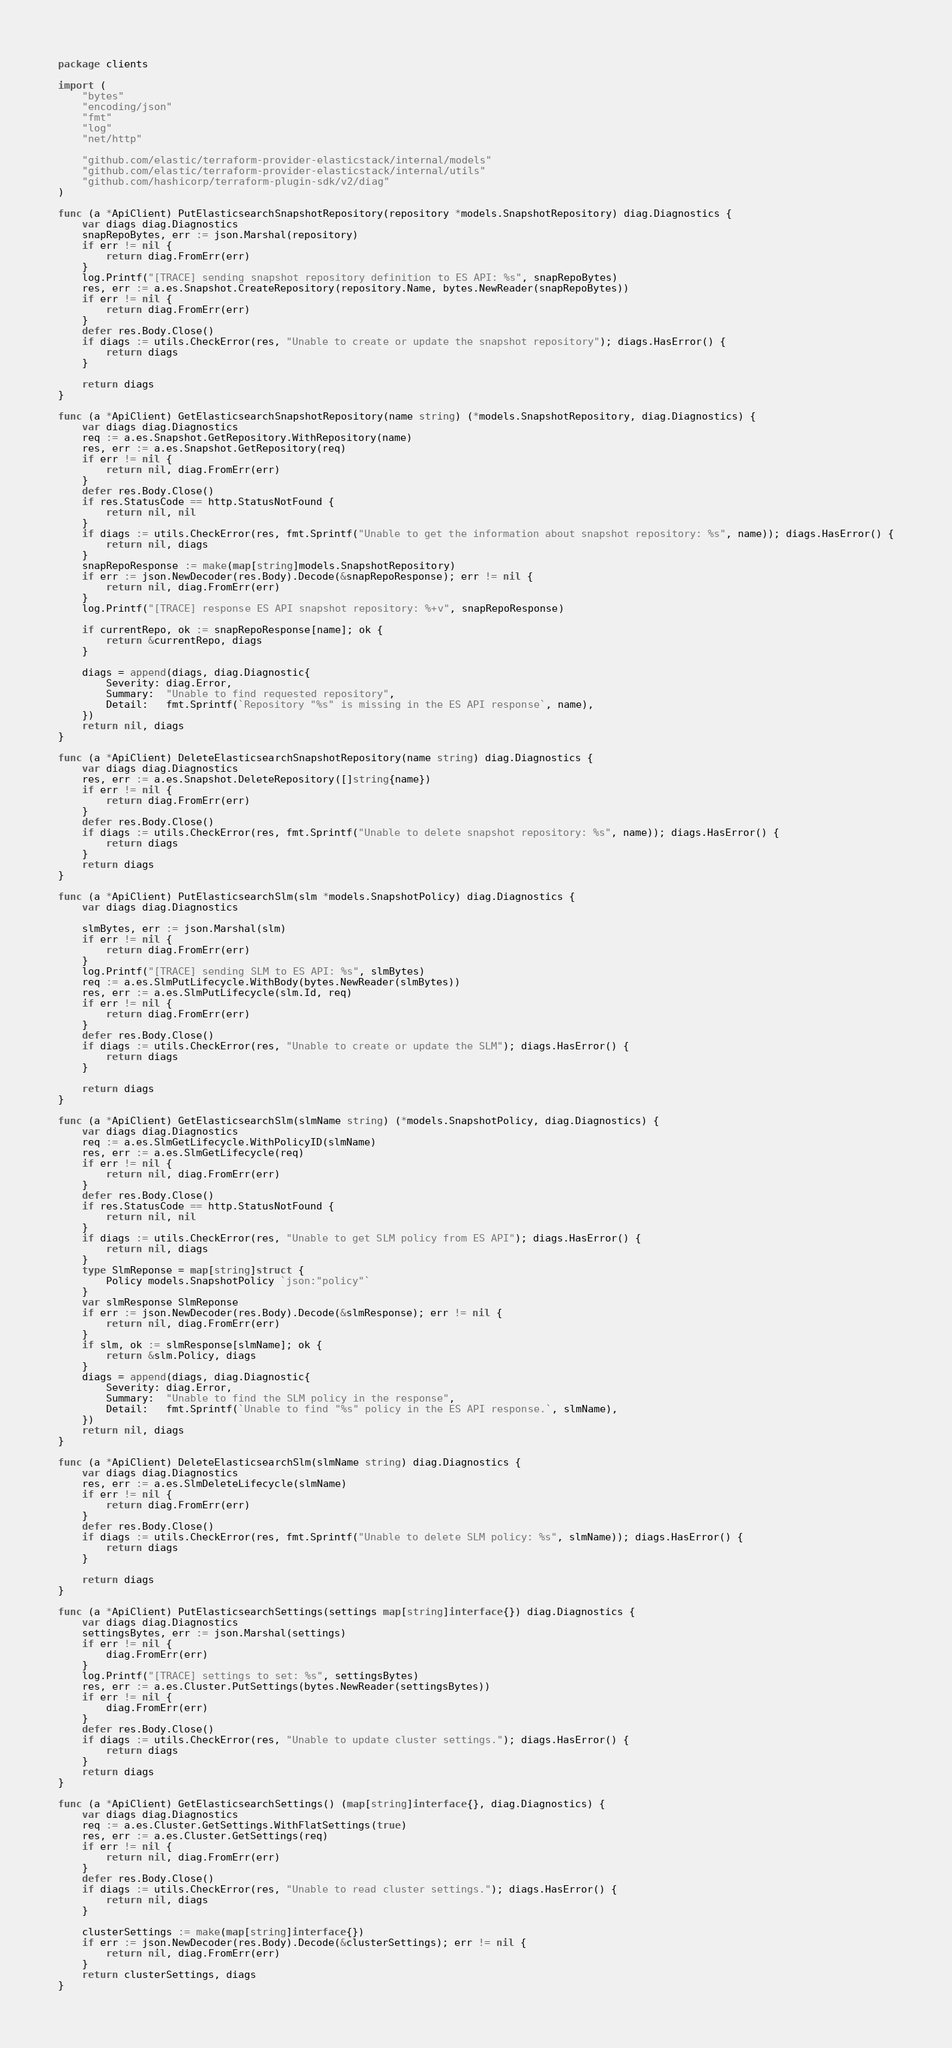Convert code to text. <code><loc_0><loc_0><loc_500><loc_500><_Go_>package clients

import (
	"bytes"
	"encoding/json"
	"fmt"
	"log"
	"net/http"

	"github.com/elastic/terraform-provider-elasticstack/internal/models"
	"github.com/elastic/terraform-provider-elasticstack/internal/utils"
	"github.com/hashicorp/terraform-plugin-sdk/v2/diag"
)

func (a *ApiClient) PutElasticsearchSnapshotRepository(repository *models.SnapshotRepository) diag.Diagnostics {
	var diags diag.Diagnostics
	snapRepoBytes, err := json.Marshal(repository)
	if err != nil {
		return diag.FromErr(err)
	}
	log.Printf("[TRACE] sending snapshot repository definition to ES API: %s", snapRepoBytes)
	res, err := a.es.Snapshot.CreateRepository(repository.Name, bytes.NewReader(snapRepoBytes))
	if err != nil {
		return diag.FromErr(err)
	}
	defer res.Body.Close()
	if diags := utils.CheckError(res, "Unable to create or update the snapshot repository"); diags.HasError() {
		return diags
	}

	return diags
}

func (a *ApiClient) GetElasticsearchSnapshotRepository(name string) (*models.SnapshotRepository, diag.Diagnostics) {
	var diags diag.Diagnostics
	req := a.es.Snapshot.GetRepository.WithRepository(name)
	res, err := a.es.Snapshot.GetRepository(req)
	if err != nil {
		return nil, diag.FromErr(err)
	}
	defer res.Body.Close()
	if res.StatusCode == http.StatusNotFound {
		return nil, nil
	}
	if diags := utils.CheckError(res, fmt.Sprintf("Unable to get the information about snapshot repository: %s", name)); diags.HasError() {
		return nil, diags
	}
	snapRepoResponse := make(map[string]models.SnapshotRepository)
	if err := json.NewDecoder(res.Body).Decode(&snapRepoResponse); err != nil {
		return nil, diag.FromErr(err)
	}
	log.Printf("[TRACE] response ES API snapshot repository: %+v", snapRepoResponse)

	if currentRepo, ok := snapRepoResponse[name]; ok {
		return &currentRepo, diags
	}

	diags = append(diags, diag.Diagnostic{
		Severity: diag.Error,
		Summary:  "Unable to find requested repository",
		Detail:   fmt.Sprintf(`Repository "%s" is missing in the ES API response`, name),
	})
	return nil, diags
}

func (a *ApiClient) DeleteElasticsearchSnapshotRepository(name string) diag.Diagnostics {
	var diags diag.Diagnostics
	res, err := a.es.Snapshot.DeleteRepository([]string{name})
	if err != nil {
		return diag.FromErr(err)
	}
	defer res.Body.Close()
	if diags := utils.CheckError(res, fmt.Sprintf("Unable to delete snapshot repository: %s", name)); diags.HasError() {
		return diags
	}
	return diags
}

func (a *ApiClient) PutElasticsearchSlm(slm *models.SnapshotPolicy) diag.Diagnostics {
	var diags diag.Diagnostics

	slmBytes, err := json.Marshal(slm)
	if err != nil {
		return diag.FromErr(err)
	}
	log.Printf("[TRACE] sending SLM to ES API: %s", slmBytes)
	req := a.es.SlmPutLifecycle.WithBody(bytes.NewReader(slmBytes))
	res, err := a.es.SlmPutLifecycle(slm.Id, req)
	if err != nil {
		return diag.FromErr(err)
	}
	defer res.Body.Close()
	if diags := utils.CheckError(res, "Unable to create or update the SLM"); diags.HasError() {
		return diags
	}

	return diags
}

func (a *ApiClient) GetElasticsearchSlm(slmName string) (*models.SnapshotPolicy, diag.Diagnostics) {
	var diags diag.Diagnostics
	req := a.es.SlmGetLifecycle.WithPolicyID(slmName)
	res, err := a.es.SlmGetLifecycle(req)
	if err != nil {
		return nil, diag.FromErr(err)
	}
	defer res.Body.Close()
	if res.StatusCode == http.StatusNotFound {
		return nil, nil
	}
	if diags := utils.CheckError(res, "Unable to get SLM policy from ES API"); diags.HasError() {
		return nil, diags
	}
	type SlmReponse = map[string]struct {
		Policy models.SnapshotPolicy `json:"policy"`
	}
	var slmResponse SlmReponse
	if err := json.NewDecoder(res.Body).Decode(&slmResponse); err != nil {
		return nil, diag.FromErr(err)
	}
	if slm, ok := slmResponse[slmName]; ok {
		return &slm.Policy, diags
	}
	diags = append(diags, diag.Diagnostic{
		Severity: diag.Error,
		Summary:  "Unable to find the SLM policy in the response",
		Detail:   fmt.Sprintf(`Unable to find "%s" policy in the ES API response.`, slmName),
	})
	return nil, diags
}

func (a *ApiClient) DeleteElasticsearchSlm(slmName string) diag.Diagnostics {
	var diags diag.Diagnostics
	res, err := a.es.SlmDeleteLifecycle(slmName)
	if err != nil {
		return diag.FromErr(err)
	}
	defer res.Body.Close()
	if diags := utils.CheckError(res, fmt.Sprintf("Unable to delete SLM policy: %s", slmName)); diags.HasError() {
		return diags
	}

	return diags
}

func (a *ApiClient) PutElasticsearchSettings(settings map[string]interface{}) diag.Diagnostics {
	var diags diag.Diagnostics
	settingsBytes, err := json.Marshal(settings)
	if err != nil {
		diag.FromErr(err)
	}
	log.Printf("[TRACE] settings to set: %s", settingsBytes)
	res, err := a.es.Cluster.PutSettings(bytes.NewReader(settingsBytes))
	if err != nil {
		diag.FromErr(err)
	}
	defer res.Body.Close()
	if diags := utils.CheckError(res, "Unable to update cluster settings."); diags.HasError() {
		return diags
	}
	return diags
}

func (a *ApiClient) GetElasticsearchSettings() (map[string]interface{}, diag.Diagnostics) {
	var diags diag.Diagnostics
	req := a.es.Cluster.GetSettings.WithFlatSettings(true)
	res, err := a.es.Cluster.GetSettings(req)
	if err != nil {
		return nil, diag.FromErr(err)
	}
	defer res.Body.Close()
	if diags := utils.CheckError(res, "Unable to read cluster settings."); diags.HasError() {
		return nil, diags
	}

	clusterSettings := make(map[string]interface{})
	if err := json.NewDecoder(res.Body).Decode(&clusterSettings); err != nil {
		return nil, diag.FromErr(err)
	}
	return clusterSettings, diags
}
</code> 